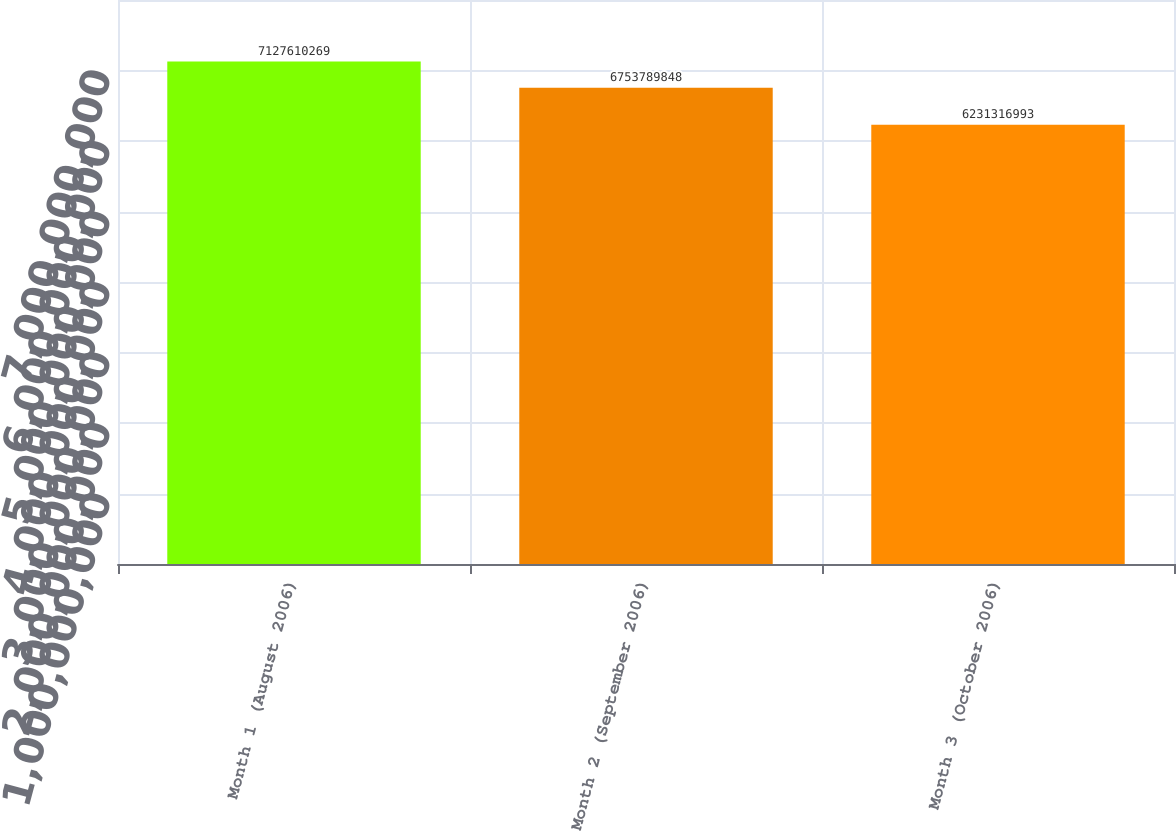Convert chart to OTSL. <chart><loc_0><loc_0><loc_500><loc_500><bar_chart><fcel>Month 1 (August 2006)<fcel>Month 2 (September 2006)<fcel>Month 3 (October 2006)<nl><fcel>7.12761e+09<fcel>6.75379e+09<fcel>6.23132e+09<nl></chart> 